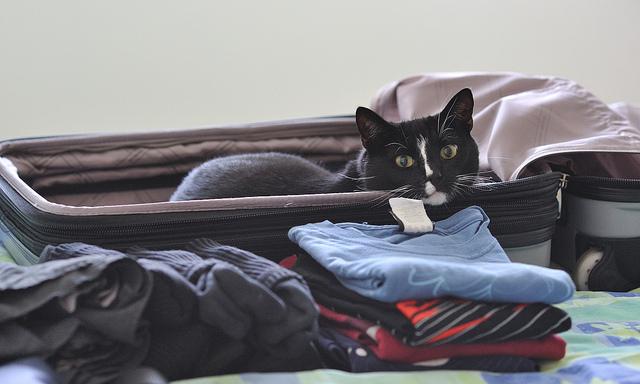What shirt will the cat where?
Answer briefly. None. Who is inside the suitcase?
Give a very brief answer. Cat. How many shirts are in the stack?
Short answer required. 4. 